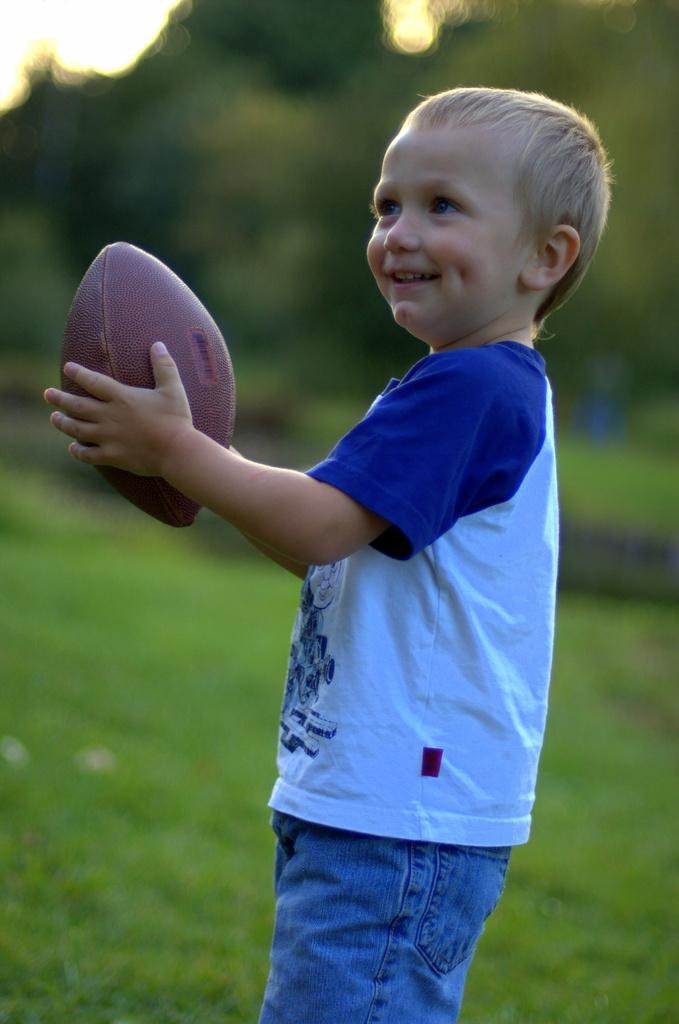What is the main subject of the image? The main subject of the image is a kid. What is the kid holding in the image? The kid is holding a rugby ball. What can be seen in the background of the image? There is greenery visible in the background of the image. What is the color of the ground in the image? The ground is green with grass. What type of rain can be seen falling in the image? There is no rain visible in the image. Can you describe the rat that is present in the image? There are no rats present in the image. 